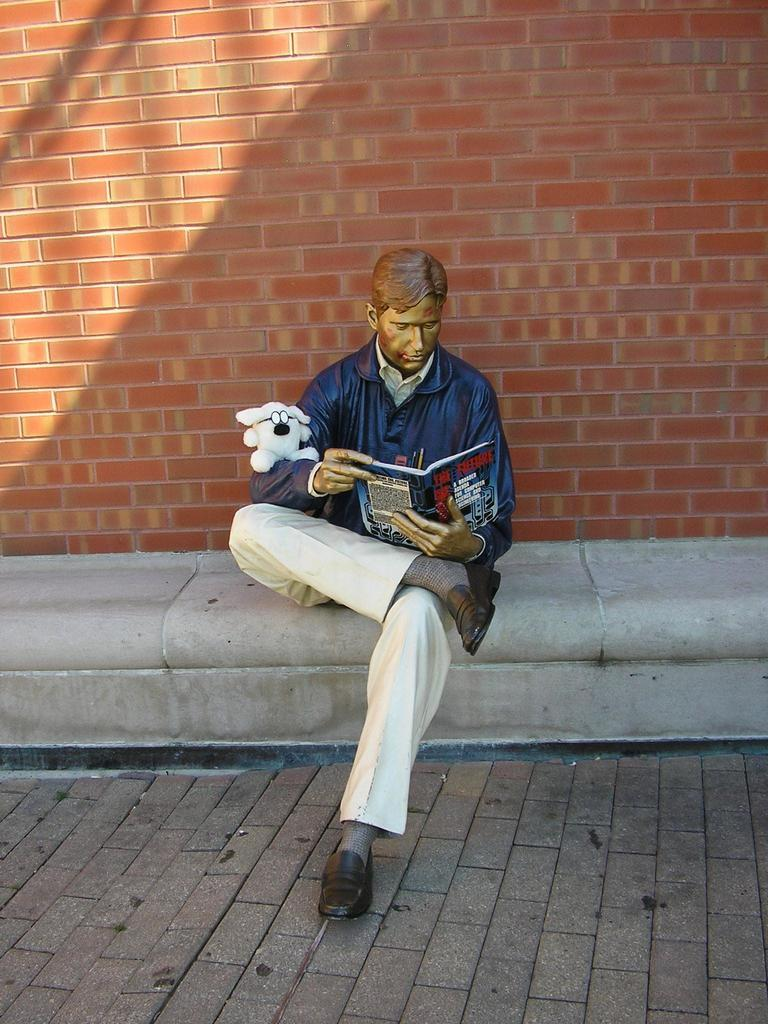What is the main subject of the image? There is a statue of a person in the image. What is the person in the statue holding? The person is holding an object. What can be seen beneath the statue in the image? The ground is visible in the image. What is present in the background of the image? There is a brick wall in the background of the image. What type of operation is being performed on the statue in the image? There is no operation being performed on the statue in the image; it is a static statue. 